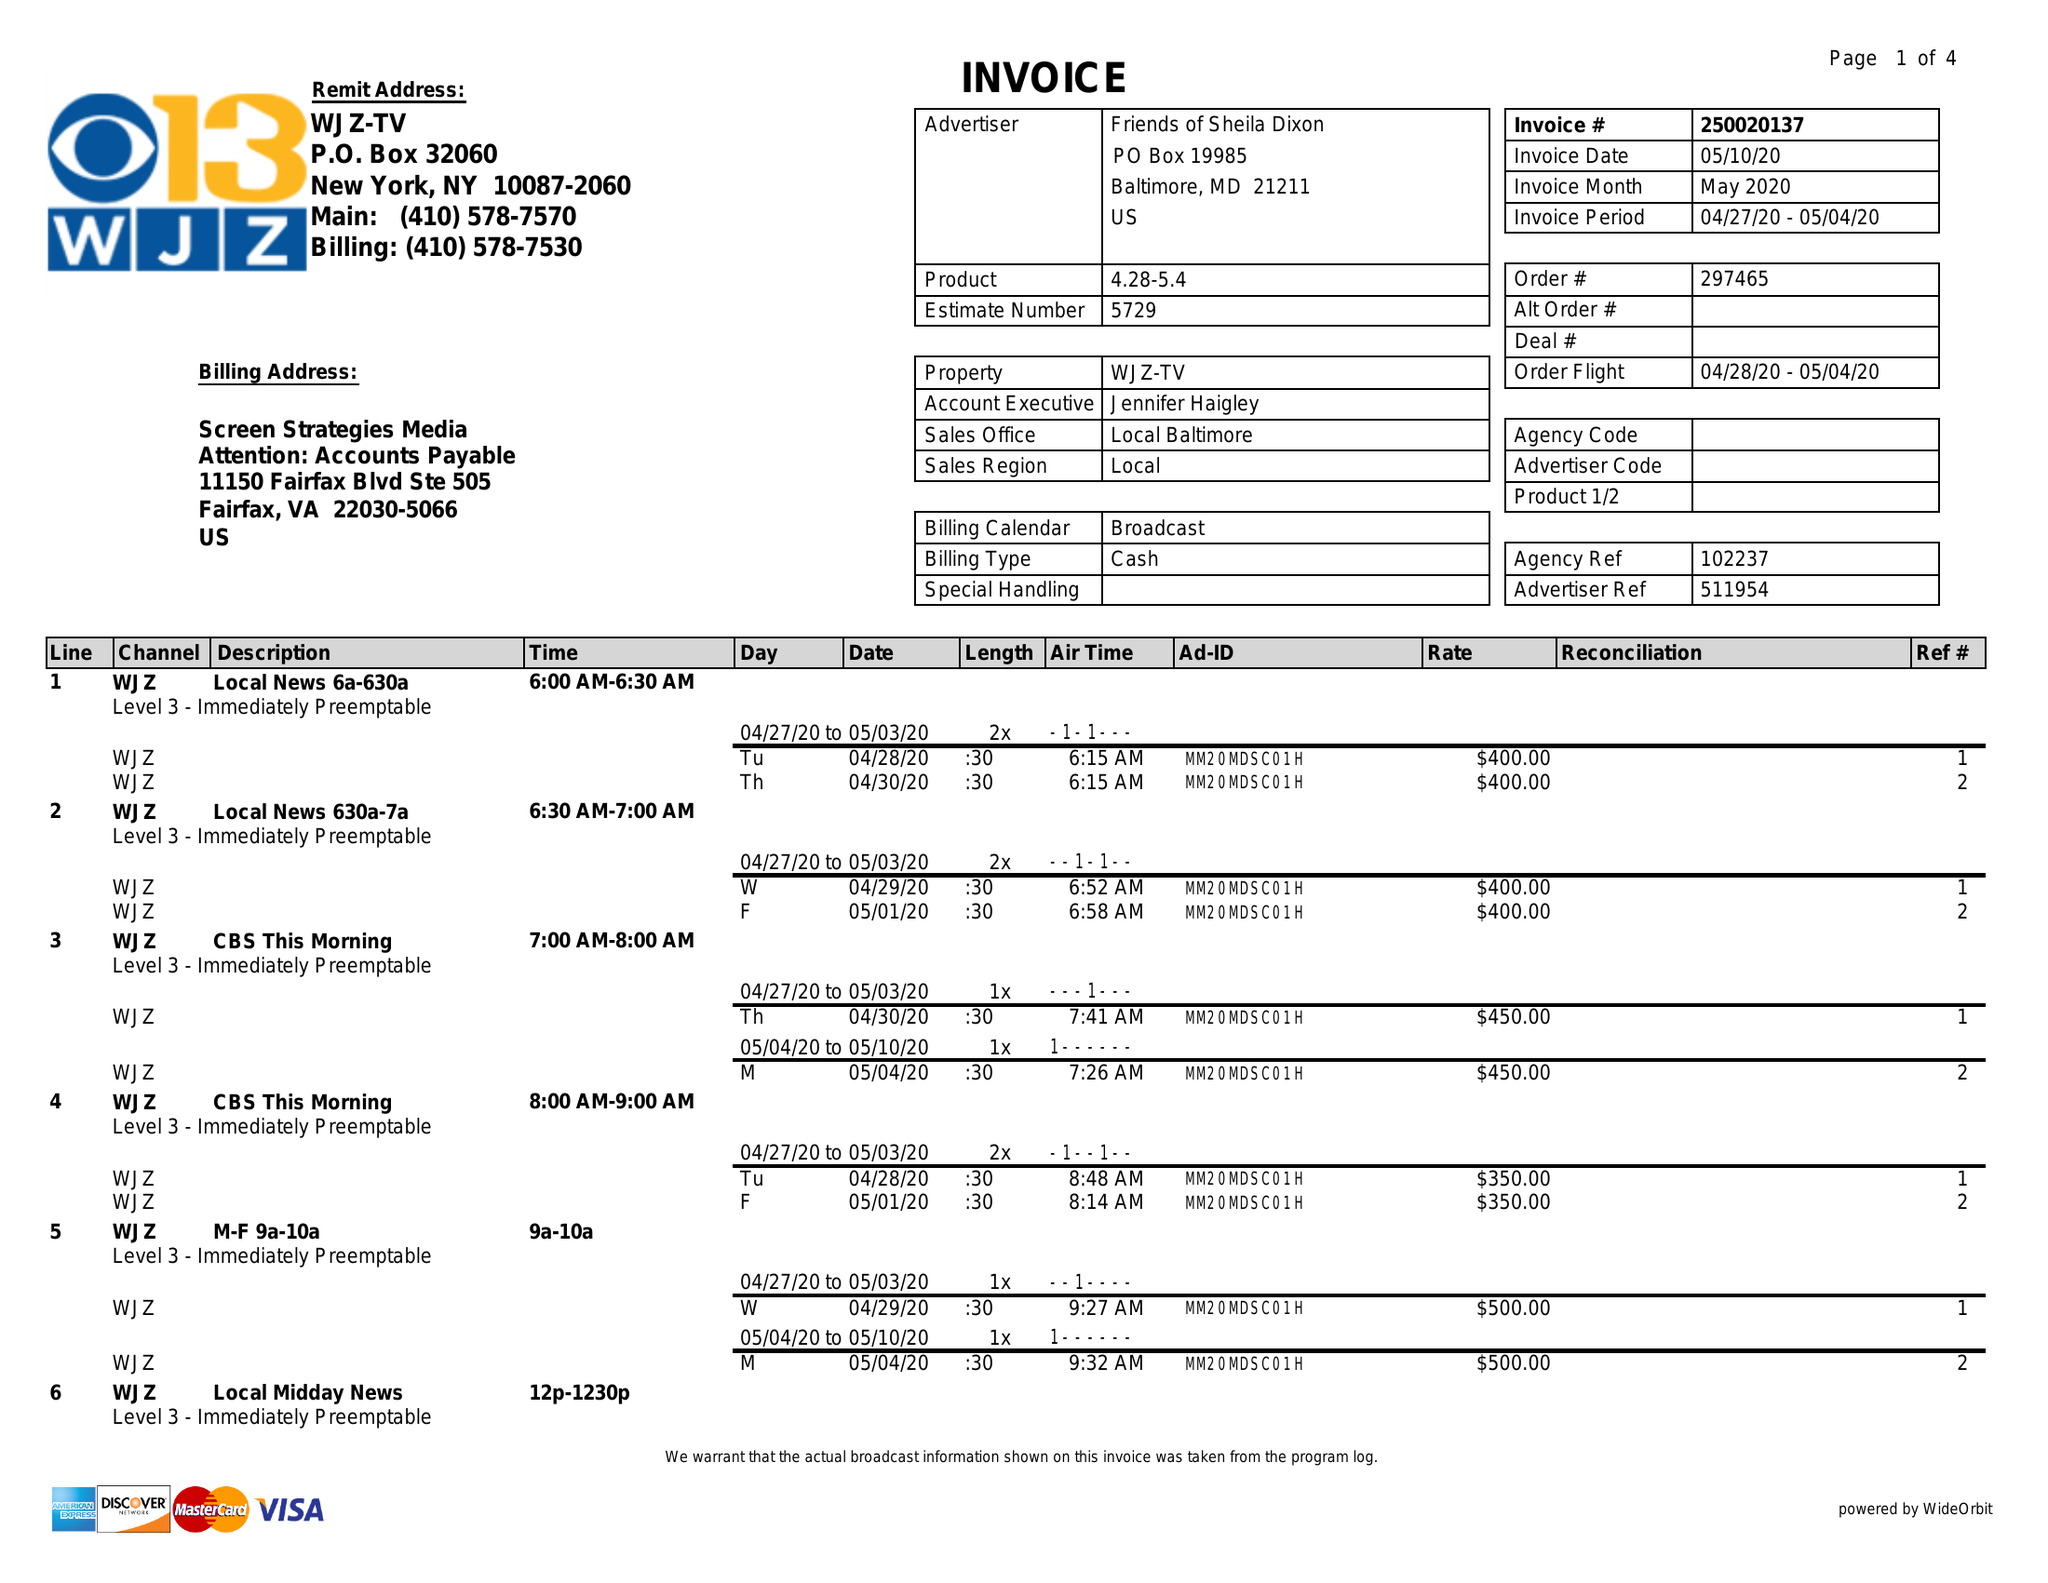What is the value for the advertiser?
Answer the question using a single word or phrase. FRIENDS OF SHEILA DIXON 